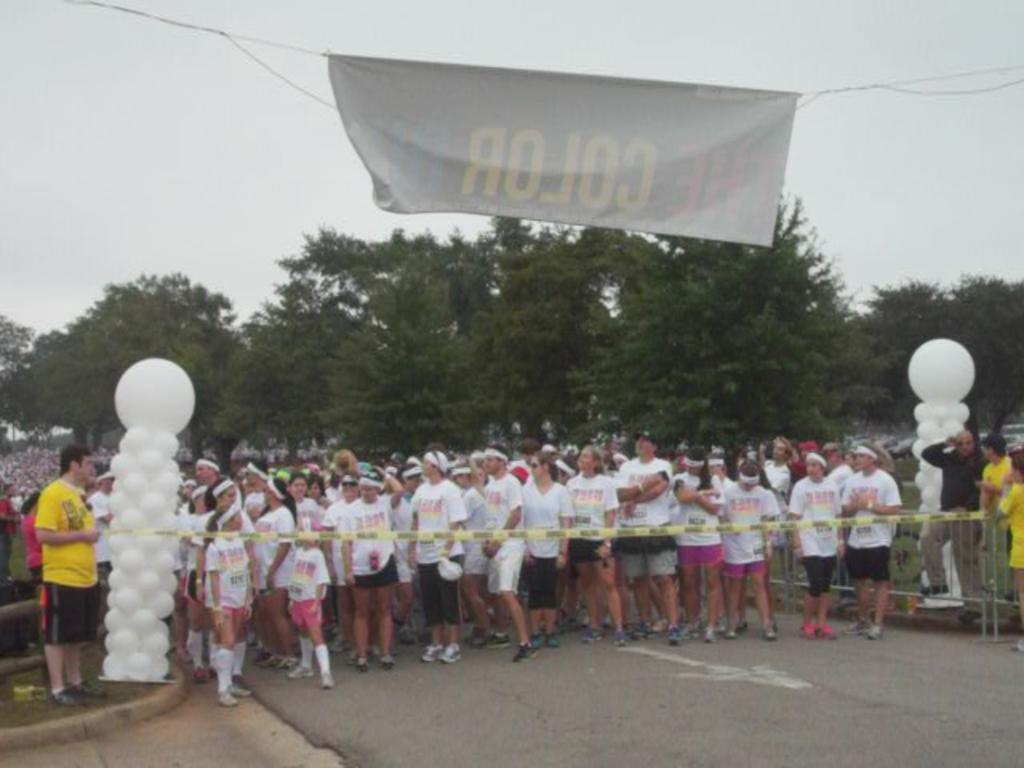What is happening on the road in the image? There is a group of people on the road in the image. What can be seen in the image besides the people on the road? There are balloons, trees, a banner, and a fence visible in the image. What is the purpose of the banner in the image? The purpose of the banner cannot be determined from the image alone. What is visible in the background of the image? The sky is visible in the background of the image. What type of teeth can be seen on the bat in the image? There is no bat or teeth present in the image. What color is the chalk used to draw on the fence in the image? There is no chalk or drawing on the fence in the image. 